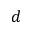Convert formula to latex. <formula><loc_0><loc_0><loc_500><loc_500>d</formula> 